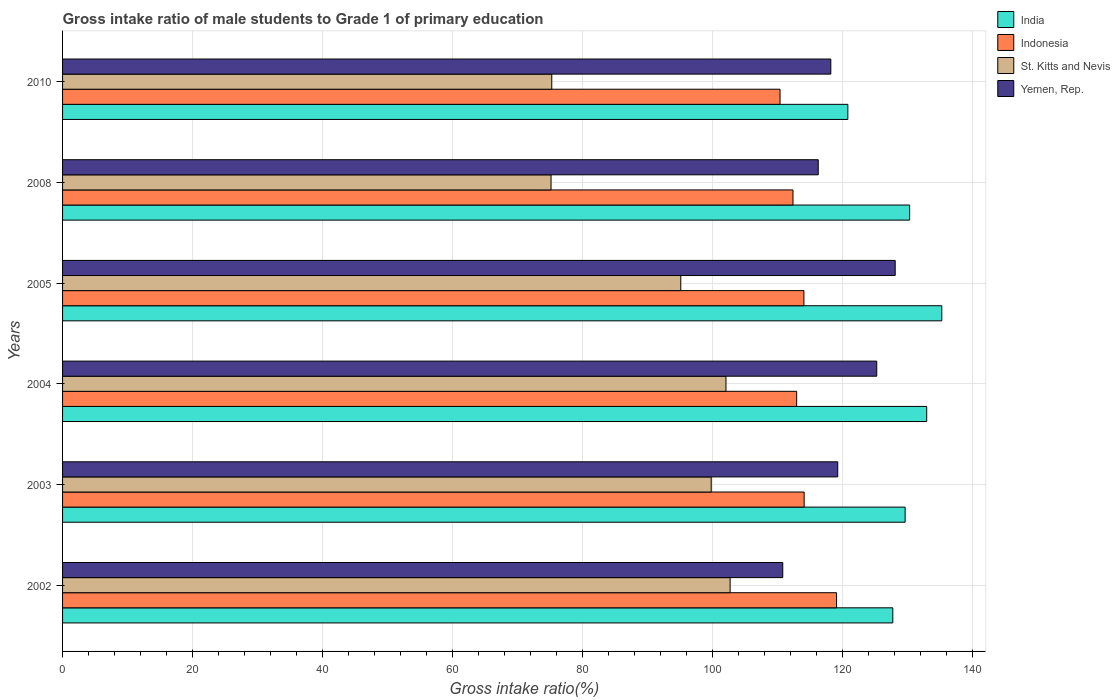How many different coloured bars are there?
Your response must be concise. 4. How many groups of bars are there?
Keep it short and to the point. 6. Are the number of bars per tick equal to the number of legend labels?
Keep it short and to the point. Yes. Are the number of bars on each tick of the Y-axis equal?
Offer a very short reply. Yes. What is the label of the 3rd group of bars from the top?
Offer a very short reply. 2005. In how many cases, is the number of bars for a given year not equal to the number of legend labels?
Provide a short and direct response. 0. What is the gross intake ratio in Yemen, Rep. in 2003?
Give a very brief answer. 119.26. Across all years, what is the maximum gross intake ratio in India?
Offer a very short reply. 135.27. Across all years, what is the minimum gross intake ratio in Yemen, Rep.?
Your answer should be very brief. 110.8. What is the total gross intake ratio in Indonesia in the graph?
Your answer should be compact. 682.92. What is the difference between the gross intake ratio in India in 2002 and that in 2004?
Keep it short and to the point. -5.22. What is the difference between the gross intake ratio in St. Kitts and Nevis in 2004 and the gross intake ratio in India in 2005?
Offer a terse response. -33.21. What is the average gross intake ratio in Yemen, Rep. per year?
Your answer should be compact. 119.65. In the year 2010, what is the difference between the gross intake ratio in St. Kitts and Nevis and gross intake ratio in Yemen, Rep.?
Your answer should be compact. -42.93. What is the ratio of the gross intake ratio in Indonesia in 2003 to that in 2005?
Your answer should be compact. 1. Is the difference between the gross intake ratio in St. Kitts and Nevis in 2004 and 2005 greater than the difference between the gross intake ratio in Yemen, Rep. in 2004 and 2005?
Your answer should be compact. Yes. What is the difference between the highest and the second highest gross intake ratio in Indonesia?
Provide a succinct answer. 4.98. What is the difference between the highest and the lowest gross intake ratio in Indonesia?
Your answer should be compact. 8.69. In how many years, is the gross intake ratio in Indonesia greater than the average gross intake ratio in Indonesia taken over all years?
Make the answer very short. 3. Is it the case that in every year, the sum of the gross intake ratio in St. Kitts and Nevis and gross intake ratio in Yemen, Rep. is greater than the sum of gross intake ratio in Indonesia and gross intake ratio in India?
Ensure brevity in your answer.  No. What does the 3rd bar from the bottom in 2002 represents?
Your answer should be compact. St. Kitts and Nevis. Is it the case that in every year, the sum of the gross intake ratio in Indonesia and gross intake ratio in India is greater than the gross intake ratio in Yemen, Rep.?
Offer a terse response. Yes. How many bars are there?
Your answer should be very brief. 24. Are all the bars in the graph horizontal?
Ensure brevity in your answer.  Yes. How many years are there in the graph?
Your response must be concise. 6. What is the difference between two consecutive major ticks on the X-axis?
Your answer should be compact. 20. Are the values on the major ticks of X-axis written in scientific E-notation?
Provide a short and direct response. No. Does the graph contain grids?
Your response must be concise. Yes. How many legend labels are there?
Offer a very short reply. 4. How are the legend labels stacked?
Provide a short and direct response. Vertical. What is the title of the graph?
Your response must be concise. Gross intake ratio of male students to Grade 1 of primary education. Does "Burkina Faso" appear as one of the legend labels in the graph?
Ensure brevity in your answer.  No. What is the label or title of the X-axis?
Your response must be concise. Gross intake ratio(%). What is the label or title of the Y-axis?
Provide a succinct answer. Years. What is the Gross intake ratio(%) of India in 2002?
Your answer should be compact. 127.73. What is the Gross intake ratio(%) of Indonesia in 2002?
Offer a terse response. 119.08. What is the Gross intake ratio(%) in St. Kitts and Nevis in 2002?
Provide a short and direct response. 102.7. What is the Gross intake ratio(%) of Yemen, Rep. in 2002?
Your response must be concise. 110.8. What is the Gross intake ratio(%) of India in 2003?
Ensure brevity in your answer.  129.63. What is the Gross intake ratio(%) in Indonesia in 2003?
Provide a succinct answer. 114.09. What is the Gross intake ratio(%) of St. Kitts and Nevis in 2003?
Provide a short and direct response. 99.79. What is the Gross intake ratio(%) of Yemen, Rep. in 2003?
Your response must be concise. 119.26. What is the Gross intake ratio(%) in India in 2004?
Give a very brief answer. 132.94. What is the Gross intake ratio(%) in Indonesia in 2004?
Offer a very short reply. 112.94. What is the Gross intake ratio(%) of St. Kitts and Nevis in 2004?
Give a very brief answer. 102.06. What is the Gross intake ratio(%) in Yemen, Rep. in 2004?
Give a very brief answer. 125.26. What is the Gross intake ratio(%) of India in 2005?
Give a very brief answer. 135.27. What is the Gross intake ratio(%) in Indonesia in 2005?
Your answer should be compact. 114.06. What is the Gross intake ratio(%) of St. Kitts and Nevis in 2005?
Your answer should be very brief. 95.11. What is the Gross intake ratio(%) in Yemen, Rep. in 2005?
Provide a succinct answer. 128.1. What is the Gross intake ratio(%) in India in 2008?
Your response must be concise. 130.32. What is the Gross intake ratio(%) in Indonesia in 2008?
Make the answer very short. 112.37. What is the Gross intake ratio(%) in St. Kitts and Nevis in 2008?
Offer a very short reply. 75.15. What is the Gross intake ratio(%) in Yemen, Rep. in 2008?
Give a very brief answer. 116.26. What is the Gross intake ratio(%) in India in 2010?
Offer a very short reply. 120.81. What is the Gross intake ratio(%) of Indonesia in 2010?
Provide a succinct answer. 110.38. What is the Gross intake ratio(%) of St. Kitts and Nevis in 2010?
Provide a short and direct response. 75.26. What is the Gross intake ratio(%) of Yemen, Rep. in 2010?
Your response must be concise. 118.19. Across all years, what is the maximum Gross intake ratio(%) in India?
Make the answer very short. 135.27. Across all years, what is the maximum Gross intake ratio(%) in Indonesia?
Ensure brevity in your answer.  119.08. Across all years, what is the maximum Gross intake ratio(%) of St. Kitts and Nevis?
Provide a short and direct response. 102.7. Across all years, what is the maximum Gross intake ratio(%) in Yemen, Rep.?
Provide a short and direct response. 128.1. Across all years, what is the minimum Gross intake ratio(%) in India?
Offer a terse response. 120.81. Across all years, what is the minimum Gross intake ratio(%) of Indonesia?
Your response must be concise. 110.38. Across all years, what is the minimum Gross intake ratio(%) of St. Kitts and Nevis?
Offer a very short reply. 75.15. Across all years, what is the minimum Gross intake ratio(%) of Yemen, Rep.?
Provide a succinct answer. 110.8. What is the total Gross intake ratio(%) in India in the graph?
Your answer should be very brief. 776.7. What is the total Gross intake ratio(%) of Indonesia in the graph?
Your answer should be compact. 682.92. What is the total Gross intake ratio(%) in St. Kitts and Nevis in the graph?
Ensure brevity in your answer.  550.08. What is the total Gross intake ratio(%) of Yemen, Rep. in the graph?
Offer a very short reply. 717.87. What is the difference between the Gross intake ratio(%) in India in 2002 and that in 2003?
Your answer should be compact. -1.9. What is the difference between the Gross intake ratio(%) in Indonesia in 2002 and that in 2003?
Keep it short and to the point. 4.98. What is the difference between the Gross intake ratio(%) of St. Kitts and Nevis in 2002 and that in 2003?
Your response must be concise. 2.91. What is the difference between the Gross intake ratio(%) in Yemen, Rep. in 2002 and that in 2003?
Make the answer very short. -8.46. What is the difference between the Gross intake ratio(%) of India in 2002 and that in 2004?
Offer a very short reply. -5.22. What is the difference between the Gross intake ratio(%) in Indonesia in 2002 and that in 2004?
Offer a very short reply. 6.14. What is the difference between the Gross intake ratio(%) in St. Kitts and Nevis in 2002 and that in 2004?
Ensure brevity in your answer.  0.64. What is the difference between the Gross intake ratio(%) in Yemen, Rep. in 2002 and that in 2004?
Your answer should be very brief. -14.46. What is the difference between the Gross intake ratio(%) in India in 2002 and that in 2005?
Make the answer very short. -7.54. What is the difference between the Gross intake ratio(%) in Indonesia in 2002 and that in 2005?
Offer a terse response. 5.02. What is the difference between the Gross intake ratio(%) in St. Kitts and Nevis in 2002 and that in 2005?
Your answer should be very brief. 7.59. What is the difference between the Gross intake ratio(%) of Yemen, Rep. in 2002 and that in 2005?
Your answer should be compact. -17.3. What is the difference between the Gross intake ratio(%) of India in 2002 and that in 2008?
Your answer should be very brief. -2.59. What is the difference between the Gross intake ratio(%) of Indonesia in 2002 and that in 2008?
Your response must be concise. 6.7. What is the difference between the Gross intake ratio(%) of St. Kitts and Nevis in 2002 and that in 2008?
Keep it short and to the point. 27.55. What is the difference between the Gross intake ratio(%) of Yemen, Rep. in 2002 and that in 2008?
Make the answer very short. -5.46. What is the difference between the Gross intake ratio(%) of India in 2002 and that in 2010?
Offer a very short reply. 6.92. What is the difference between the Gross intake ratio(%) in Indonesia in 2002 and that in 2010?
Your answer should be very brief. 8.69. What is the difference between the Gross intake ratio(%) in St. Kitts and Nevis in 2002 and that in 2010?
Keep it short and to the point. 27.44. What is the difference between the Gross intake ratio(%) in Yemen, Rep. in 2002 and that in 2010?
Your response must be concise. -7.39. What is the difference between the Gross intake ratio(%) of India in 2003 and that in 2004?
Your response must be concise. -3.32. What is the difference between the Gross intake ratio(%) of Indonesia in 2003 and that in 2004?
Your answer should be compact. 1.16. What is the difference between the Gross intake ratio(%) in St. Kitts and Nevis in 2003 and that in 2004?
Your answer should be compact. -2.27. What is the difference between the Gross intake ratio(%) of Yemen, Rep. in 2003 and that in 2004?
Your answer should be very brief. -6. What is the difference between the Gross intake ratio(%) in India in 2003 and that in 2005?
Make the answer very short. -5.64. What is the difference between the Gross intake ratio(%) in Indonesia in 2003 and that in 2005?
Keep it short and to the point. 0.04. What is the difference between the Gross intake ratio(%) of St. Kitts and Nevis in 2003 and that in 2005?
Your answer should be compact. 4.68. What is the difference between the Gross intake ratio(%) in Yemen, Rep. in 2003 and that in 2005?
Make the answer very short. -8.84. What is the difference between the Gross intake ratio(%) in India in 2003 and that in 2008?
Provide a succinct answer. -0.69. What is the difference between the Gross intake ratio(%) of Indonesia in 2003 and that in 2008?
Ensure brevity in your answer.  1.72. What is the difference between the Gross intake ratio(%) in St. Kitts and Nevis in 2003 and that in 2008?
Your response must be concise. 24.64. What is the difference between the Gross intake ratio(%) of Yemen, Rep. in 2003 and that in 2008?
Offer a terse response. 3. What is the difference between the Gross intake ratio(%) in India in 2003 and that in 2010?
Make the answer very short. 8.82. What is the difference between the Gross intake ratio(%) in Indonesia in 2003 and that in 2010?
Keep it short and to the point. 3.71. What is the difference between the Gross intake ratio(%) in St. Kitts and Nevis in 2003 and that in 2010?
Provide a succinct answer. 24.53. What is the difference between the Gross intake ratio(%) in Yemen, Rep. in 2003 and that in 2010?
Your answer should be compact. 1.06. What is the difference between the Gross intake ratio(%) in India in 2004 and that in 2005?
Offer a terse response. -2.32. What is the difference between the Gross intake ratio(%) of Indonesia in 2004 and that in 2005?
Give a very brief answer. -1.12. What is the difference between the Gross intake ratio(%) of St. Kitts and Nevis in 2004 and that in 2005?
Your answer should be very brief. 6.95. What is the difference between the Gross intake ratio(%) in Yemen, Rep. in 2004 and that in 2005?
Ensure brevity in your answer.  -2.84. What is the difference between the Gross intake ratio(%) in India in 2004 and that in 2008?
Provide a short and direct response. 2.62. What is the difference between the Gross intake ratio(%) of Indonesia in 2004 and that in 2008?
Offer a very short reply. 0.56. What is the difference between the Gross intake ratio(%) in St. Kitts and Nevis in 2004 and that in 2008?
Offer a very short reply. 26.91. What is the difference between the Gross intake ratio(%) in Yemen, Rep. in 2004 and that in 2008?
Your answer should be very brief. 9. What is the difference between the Gross intake ratio(%) of India in 2004 and that in 2010?
Your answer should be very brief. 12.13. What is the difference between the Gross intake ratio(%) of Indonesia in 2004 and that in 2010?
Ensure brevity in your answer.  2.56. What is the difference between the Gross intake ratio(%) in St. Kitts and Nevis in 2004 and that in 2010?
Provide a succinct answer. 26.8. What is the difference between the Gross intake ratio(%) in Yemen, Rep. in 2004 and that in 2010?
Offer a terse response. 7.07. What is the difference between the Gross intake ratio(%) of India in 2005 and that in 2008?
Give a very brief answer. 4.95. What is the difference between the Gross intake ratio(%) in Indonesia in 2005 and that in 2008?
Keep it short and to the point. 1.68. What is the difference between the Gross intake ratio(%) in St. Kitts and Nevis in 2005 and that in 2008?
Your response must be concise. 19.96. What is the difference between the Gross intake ratio(%) of Yemen, Rep. in 2005 and that in 2008?
Provide a succinct answer. 11.84. What is the difference between the Gross intake ratio(%) in India in 2005 and that in 2010?
Give a very brief answer. 14.46. What is the difference between the Gross intake ratio(%) in Indonesia in 2005 and that in 2010?
Ensure brevity in your answer.  3.67. What is the difference between the Gross intake ratio(%) in St. Kitts and Nevis in 2005 and that in 2010?
Offer a very short reply. 19.85. What is the difference between the Gross intake ratio(%) in Yemen, Rep. in 2005 and that in 2010?
Your response must be concise. 9.91. What is the difference between the Gross intake ratio(%) of India in 2008 and that in 2010?
Offer a very short reply. 9.51. What is the difference between the Gross intake ratio(%) in Indonesia in 2008 and that in 2010?
Your answer should be very brief. 1.99. What is the difference between the Gross intake ratio(%) in St. Kitts and Nevis in 2008 and that in 2010?
Offer a terse response. -0.11. What is the difference between the Gross intake ratio(%) of Yemen, Rep. in 2008 and that in 2010?
Make the answer very short. -1.93. What is the difference between the Gross intake ratio(%) of India in 2002 and the Gross intake ratio(%) of Indonesia in 2003?
Provide a succinct answer. 13.64. What is the difference between the Gross intake ratio(%) in India in 2002 and the Gross intake ratio(%) in St. Kitts and Nevis in 2003?
Your answer should be very brief. 27.94. What is the difference between the Gross intake ratio(%) in India in 2002 and the Gross intake ratio(%) in Yemen, Rep. in 2003?
Provide a short and direct response. 8.47. What is the difference between the Gross intake ratio(%) of Indonesia in 2002 and the Gross intake ratio(%) of St. Kitts and Nevis in 2003?
Provide a short and direct response. 19.28. What is the difference between the Gross intake ratio(%) of Indonesia in 2002 and the Gross intake ratio(%) of Yemen, Rep. in 2003?
Ensure brevity in your answer.  -0.18. What is the difference between the Gross intake ratio(%) of St. Kitts and Nevis in 2002 and the Gross intake ratio(%) of Yemen, Rep. in 2003?
Keep it short and to the point. -16.55. What is the difference between the Gross intake ratio(%) of India in 2002 and the Gross intake ratio(%) of Indonesia in 2004?
Provide a short and direct response. 14.79. What is the difference between the Gross intake ratio(%) in India in 2002 and the Gross intake ratio(%) in St. Kitts and Nevis in 2004?
Ensure brevity in your answer.  25.67. What is the difference between the Gross intake ratio(%) in India in 2002 and the Gross intake ratio(%) in Yemen, Rep. in 2004?
Your answer should be very brief. 2.47. What is the difference between the Gross intake ratio(%) of Indonesia in 2002 and the Gross intake ratio(%) of St. Kitts and Nevis in 2004?
Your response must be concise. 17.01. What is the difference between the Gross intake ratio(%) of Indonesia in 2002 and the Gross intake ratio(%) of Yemen, Rep. in 2004?
Give a very brief answer. -6.19. What is the difference between the Gross intake ratio(%) of St. Kitts and Nevis in 2002 and the Gross intake ratio(%) of Yemen, Rep. in 2004?
Your answer should be compact. -22.56. What is the difference between the Gross intake ratio(%) of India in 2002 and the Gross intake ratio(%) of Indonesia in 2005?
Provide a short and direct response. 13.67. What is the difference between the Gross intake ratio(%) in India in 2002 and the Gross intake ratio(%) in St. Kitts and Nevis in 2005?
Offer a very short reply. 32.62. What is the difference between the Gross intake ratio(%) in India in 2002 and the Gross intake ratio(%) in Yemen, Rep. in 2005?
Your answer should be very brief. -0.37. What is the difference between the Gross intake ratio(%) of Indonesia in 2002 and the Gross intake ratio(%) of St. Kitts and Nevis in 2005?
Provide a succinct answer. 23.96. What is the difference between the Gross intake ratio(%) of Indonesia in 2002 and the Gross intake ratio(%) of Yemen, Rep. in 2005?
Offer a terse response. -9.02. What is the difference between the Gross intake ratio(%) in St. Kitts and Nevis in 2002 and the Gross intake ratio(%) in Yemen, Rep. in 2005?
Provide a short and direct response. -25.4. What is the difference between the Gross intake ratio(%) in India in 2002 and the Gross intake ratio(%) in Indonesia in 2008?
Provide a short and direct response. 15.36. What is the difference between the Gross intake ratio(%) in India in 2002 and the Gross intake ratio(%) in St. Kitts and Nevis in 2008?
Your answer should be compact. 52.58. What is the difference between the Gross intake ratio(%) in India in 2002 and the Gross intake ratio(%) in Yemen, Rep. in 2008?
Ensure brevity in your answer.  11.47. What is the difference between the Gross intake ratio(%) of Indonesia in 2002 and the Gross intake ratio(%) of St. Kitts and Nevis in 2008?
Give a very brief answer. 43.92. What is the difference between the Gross intake ratio(%) in Indonesia in 2002 and the Gross intake ratio(%) in Yemen, Rep. in 2008?
Make the answer very short. 2.81. What is the difference between the Gross intake ratio(%) in St. Kitts and Nevis in 2002 and the Gross intake ratio(%) in Yemen, Rep. in 2008?
Provide a succinct answer. -13.56. What is the difference between the Gross intake ratio(%) of India in 2002 and the Gross intake ratio(%) of Indonesia in 2010?
Provide a succinct answer. 17.35. What is the difference between the Gross intake ratio(%) in India in 2002 and the Gross intake ratio(%) in St. Kitts and Nevis in 2010?
Offer a very short reply. 52.47. What is the difference between the Gross intake ratio(%) of India in 2002 and the Gross intake ratio(%) of Yemen, Rep. in 2010?
Your answer should be very brief. 9.54. What is the difference between the Gross intake ratio(%) in Indonesia in 2002 and the Gross intake ratio(%) in St. Kitts and Nevis in 2010?
Offer a terse response. 43.81. What is the difference between the Gross intake ratio(%) of Indonesia in 2002 and the Gross intake ratio(%) of Yemen, Rep. in 2010?
Provide a short and direct response. 0.88. What is the difference between the Gross intake ratio(%) of St. Kitts and Nevis in 2002 and the Gross intake ratio(%) of Yemen, Rep. in 2010?
Your answer should be very brief. -15.49. What is the difference between the Gross intake ratio(%) of India in 2003 and the Gross intake ratio(%) of Indonesia in 2004?
Keep it short and to the point. 16.69. What is the difference between the Gross intake ratio(%) in India in 2003 and the Gross intake ratio(%) in St. Kitts and Nevis in 2004?
Keep it short and to the point. 27.57. What is the difference between the Gross intake ratio(%) of India in 2003 and the Gross intake ratio(%) of Yemen, Rep. in 2004?
Provide a short and direct response. 4.37. What is the difference between the Gross intake ratio(%) in Indonesia in 2003 and the Gross intake ratio(%) in St. Kitts and Nevis in 2004?
Offer a terse response. 12.03. What is the difference between the Gross intake ratio(%) in Indonesia in 2003 and the Gross intake ratio(%) in Yemen, Rep. in 2004?
Provide a short and direct response. -11.17. What is the difference between the Gross intake ratio(%) in St. Kitts and Nevis in 2003 and the Gross intake ratio(%) in Yemen, Rep. in 2004?
Your answer should be very brief. -25.47. What is the difference between the Gross intake ratio(%) of India in 2003 and the Gross intake ratio(%) of Indonesia in 2005?
Your response must be concise. 15.57. What is the difference between the Gross intake ratio(%) in India in 2003 and the Gross intake ratio(%) in St. Kitts and Nevis in 2005?
Ensure brevity in your answer.  34.52. What is the difference between the Gross intake ratio(%) in India in 2003 and the Gross intake ratio(%) in Yemen, Rep. in 2005?
Ensure brevity in your answer.  1.53. What is the difference between the Gross intake ratio(%) of Indonesia in 2003 and the Gross intake ratio(%) of St. Kitts and Nevis in 2005?
Give a very brief answer. 18.98. What is the difference between the Gross intake ratio(%) of Indonesia in 2003 and the Gross intake ratio(%) of Yemen, Rep. in 2005?
Ensure brevity in your answer.  -14.01. What is the difference between the Gross intake ratio(%) of St. Kitts and Nevis in 2003 and the Gross intake ratio(%) of Yemen, Rep. in 2005?
Keep it short and to the point. -28.31. What is the difference between the Gross intake ratio(%) in India in 2003 and the Gross intake ratio(%) in Indonesia in 2008?
Provide a short and direct response. 17.25. What is the difference between the Gross intake ratio(%) in India in 2003 and the Gross intake ratio(%) in St. Kitts and Nevis in 2008?
Provide a short and direct response. 54.48. What is the difference between the Gross intake ratio(%) in India in 2003 and the Gross intake ratio(%) in Yemen, Rep. in 2008?
Make the answer very short. 13.37. What is the difference between the Gross intake ratio(%) of Indonesia in 2003 and the Gross intake ratio(%) of St. Kitts and Nevis in 2008?
Give a very brief answer. 38.94. What is the difference between the Gross intake ratio(%) of Indonesia in 2003 and the Gross intake ratio(%) of Yemen, Rep. in 2008?
Provide a short and direct response. -2.17. What is the difference between the Gross intake ratio(%) of St. Kitts and Nevis in 2003 and the Gross intake ratio(%) of Yemen, Rep. in 2008?
Keep it short and to the point. -16.47. What is the difference between the Gross intake ratio(%) in India in 2003 and the Gross intake ratio(%) in Indonesia in 2010?
Ensure brevity in your answer.  19.25. What is the difference between the Gross intake ratio(%) of India in 2003 and the Gross intake ratio(%) of St. Kitts and Nevis in 2010?
Offer a very short reply. 54.37. What is the difference between the Gross intake ratio(%) of India in 2003 and the Gross intake ratio(%) of Yemen, Rep. in 2010?
Your answer should be compact. 11.43. What is the difference between the Gross intake ratio(%) of Indonesia in 2003 and the Gross intake ratio(%) of St. Kitts and Nevis in 2010?
Provide a succinct answer. 38.83. What is the difference between the Gross intake ratio(%) of Indonesia in 2003 and the Gross intake ratio(%) of Yemen, Rep. in 2010?
Your response must be concise. -4.1. What is the difference between the Gross intake ratio(%) of St. Kitts and Nevis in 2003 and the Gross intake ratio(%) of Yemen, Rep. in 2010?
Provide a succinct answer. -18.4. What is the difference between the Gross intake ratio(%) in India in 2004 and the Gross intake ratio(%) in Indonesia in 2005?
Ensure brevity in your answer.  18.89. What is the difference between the Gross intake ratio(%) in India in 2004 and the Gross intake ratio(%) in St. Kitts and Nevis in 2005?
Your response must be concise. 37.83. What is the difference between the Gross intake ratio(%) in India in 2004 and the Gross intake ratio(%) in Yemen, Rep. in 2005?
Your answer should be compact. 4.85. What is the difference between the Gross intake ratio(%) in Indonesia in 2004 and the Gross intake ratio(%) in St. Kitts and Nevis in 2005?
Offer a very short reply. 17.83. What is the difference between the Gross intake ratio(%) in Indonesia in 2004 and the Gross intake ratio(%) in Yemen, Rep. in 2005?
Make the answer very short. -15.16. What is the difference between the Gross intake ratio(%) in St. Kitts and Nevis in 2004 and the Gross intake ratio(%) in Yemen, Rep. in 2005?
Provide a succinct answer. -26.04. What is the difference between the Gross intake ratio(%) in India in 2004 and the Gross intake ratio(%) in Indonesia in 2008?
Ensure brevity in your answer.  20.57. What is the difference between the Gross intake ratio(%) in India in 2004 and the Gross intake ratio(%) in St. Kitts and Nevis in 2008?
Give a very brief answer. 57.79. What is the difference between the Gross intake ratio(%) in India in 2004 and the Gross intake ratio(%) in Yemen, Rep. in 2008?
Give a very brief answer. 16.68. What is the difference between the Gross intake ratio(%) in Indonesia in 2004 and the Gross intake ratio(%) in St. Kitts and Nevis in 2008?
Your response must be concise. 37.78. What is the difference between the Gross intake ratio(%) of Indonesia in 2004 and the Gross intake ratio(%) of Yemen, Rep. in 2008?
Ensure brevity in your answer.  -3.32. What is the difference between the Gross intake ratio(%) in St. Kitts and Nevis in 2004 and the Gross intake ratio(%) in Yemen, Rep. in 2008?
Your response must be concise. -14.2. What is the difference between the Gross intake ratio(%) in India in 2004 and the Gross intake ratio(%) in Indonesia in 2010?
Ensure brevity in your answer.  22.56. What is the difference between the Gross intake ratio(%) of India in 2004 and the Gross intake ratio(%) of St. Kitts and Nevis in 2010?
Your response must be concise. 57.68. What is the difference between the Gross intake ratio(%) in India in 2004 and the Gross intake ratio(%) in Yemen, Rep. in 2010?
Provide a succinct answer. 14.75. What is the difference between the Gross intake ratio(%) of Indonesia in 2004 and the Gross intake ratio(%) of St. Kitts and Nevis in 2010?
Give a very brief answer. 37.68. What is the difference between the Gross intake ratio(%) in Indonesia in 2004 and the Gross intake ratio(%) in Yemen, Rep. in 2010?
Offer a terse response. -5.26. What is the difference between the Gross intake ratio(%) in St. Kitts and Nevis in 2004 and the Gross intake ratio(%) in Yemen, Rep. in 2010?
Your response must be concise. -16.13. What is the difference between the Gross intake ratio(%) in India in 2005 and the Gross intake ratio(%) in Indonesia in 2008?
Your answer should be very brief. 22.89. What is the difference between the Gross intake ratio(%) of India in 2005 and the Gross intake ratio(%) of St. Kitts and Nevis in 2008?
Make the answer very short. 60.11. What is the difference between the Gross intake ratio(%) in India in 2005 and the Gross intake ratio(%) in Yemen, Rep. in 2008?
Provide a succinct answer. 19.01. What is the difference between the Gross intake ratio(%) of Indonesia in 2005 and the Gross intake ratio(%) of St. Kitts and Nevis in 2008?
Provide a short and direct response. 38.9. What is the difference between the Gross intake ratio(%) of Indonesia in 2005 and the Gross intake ratio(%) of Yemen, Rep. in 2008?
Give a very brief answer. -2.21. What is the difference between the Gross intake ratio(%) in St. Kitts and Nevis in 2005 and the Gross intake ratio(%) in Yemen, Rep. in 2008?
Your answer should be compact. -21.15. What is the difference between the Gross intake ratio(%) of India in 2005 and the Gross intake ratio(%) of Indonesia in 2010?
Keep it short and to the point. 24.89. What is the difference between the Gross intake ratio(%) of India in 2005 and the Gross intake ratio(%) of St. Kitts and Nevis in 2010?
Your response must be concise. 60.01. What is the difference between the Gross intake ratio(%) in India in 2005 and the Gross intake ratio(%) in Yemen, Rep. in 2010?
Keep it short and to the point. 17.07. What is the difference between the Gross intake ratio(%) in Indonesia in 2005 and the Gross intake ratio(%) in St. Kitts and Nevis in 2010?
Offer a terse response. 38.79. What is the difference between the Gross intake ratio(%) of Indonesia in 2005 and the Gross intake ratio(%) of Yemen, Rep. in 2010?
Your answer should be very brief. -4.14. What is the difference between the Gross intake ratio(%) of St. Kitts and Nevis in 2005 and the Gross intake ratio(%) of Yemen, Rep. in 2010?
Provide a short and direct response. -23.08. What is the difference between the Gross intake ratio(%) in India in 2008 and the Gross intake ratio(%) in Indonesia in 2010?
Ensure brevity in your answer.  19.94. What is the difference between the Gross intake ratio(%) of India in 2008 and the Gross intake ratio(%) of St. Kitts and Nevis in 2010?
Offer a terse response. 55.06. What is the difference between the Gross intake ratio(%) of India in 2008 and the Gross intake ratio(%) of Yemen, Rep. in 2010?
Make the answer very short. 12.13. What is the difference between the Gross intake ratio(%) of Indonesia in 2008 and the Gross intake ratio(%) of St. Kitts and Nevis in 2010?
Your answer should be compact. 37.11. What is the difference between the Gross intake ratio(%) in Indonesia in 2008 and the Gross intake ratio(%) in Yemen, Rep. in 2010?
Provide a succinct answer. -5.82. What is the difference between the Gross intake ratio(%) in St. Kitts and Nevis in 2008 and the Gross intake ratio(%) in Yemen, Rep. in 2010?
Offer a very short reply. -43.04. What is the average Gross intake ratio(%) of India per year?
Offer a very short reply. 129.45. What is the average Gross intake ratio(%) of Indonesia per year?
Your answer should be compact. 113.82. What is the average Gross intake ratio(%) in St. Kitts and Nevis per year?
Provide a short and direct response. 91.68. What is the average Gross intake ratio(%) in Yemen, Rep. per year?
Your answer should be very brief. 119.65. In the year 2002, what is the difference between the Gross intake ratio(%) of India and Gross intake ratio(%) of Indonesia?
Your response must be concise. 8.65. In the year 2002, what is the difference between the Gross intake ratio(%) in India and Gross intake ratio(%) in St. Kitts and Nevis?
Provide a succinct answer. 25.03. In the year 2002, what is the difference between the Gross intake ratio(%) of India and Gross intake ratio(%) of Yemen, Rep.?
Provide a succinct answer. 16.93. In the year 2002, what is the difference between the Gross intake ratio(%) in Indonesia and Gross intake ratio(%) in St. Kitts and Nevis?
Make the answer very short. 16.37. In the year 2002, what is the difference between the Gross intake ratio(%) of Indonesia and Gross intake ratio(%) of Yemen, Rep.?
Provide a short and direct response. 8.27. In the year 2002, what is the difference between the Gross intake ratio(%) of St. Kitts and Nevis and Gross intake ratio(%) of Yemen, Rep.?
Offer a very short reply. -8.1. In the year 2003, what is the difference between the Gross intake ratio(%) in India and Gross intake ratio(%) in Indonesia?
Provide a succinct answer. 15.54. In the year 2003, what is the difference between the Gross intake ratio(%) in India and Gross intake ratio(%) in St. Kitts and Nevis?
Your answer should be very brief. 29.84. In the year 2003, what is the difference between the Gross intake ratio(%) in India and Gross intake ratio(%) in Yemen, Rep.?
Ensure brevity in your answer.  10.37. In the year 2003, what is the difference between the Gross intake ratio(%) in Indonesia and Gross intake ratio(%) in St. Kitts and Nevis?
Your answer should be very brief. 14.3. In the year 2003, what is the difference between the Gross intake ratio(%) of Indonesia and Gross intake ratio(%) of Yemen, Rep.?
Your response must be concise. -5.17. In the year 2003, what is the difference between the Gross intake ratio(%) in St. Kitts and Nevis and Gross intake ratio(%) in Yemen, Rep.?
Ensure brevity in your answer.  -19.47. In the year 2004, what is the difference between the Gross intake ratio(%) of India and Gross intake ratio(%) of Indonesia?
Keep it short and to the point. 20.01. In the year 2004, what is the difference between the Gross intake ratio(%) in India and Gross intake ratio(%) in St. Kitts and Nevis?
Provide a succinct answer. 30.88. In the year 2004, what is the difference between the Gross intake ratio(%) of India and Gross intake ratio(%) of Yemen, Rep.?
Offer a terse response. 7.68. In the year 2004, what is the difference between the Gross intake ratio(%) in Indonesia and Gross intake ratio(%) in St. Kitts and Nevis?
Provide a short and direct response. 10.88. In the year 2004, what is the difference between the Gross intake ratio(%) in Indonesia and Gross intake ratio(%) in Yemen, Rep.?
Offer a very short reply. -12.32. In the year 2004, what is the difference between the Gross intake ratio(%) in St. Kitts and Nevis and Gross intake ratio(%) in Yemen, Rep.?
Provide a succinct answer. -23.2. In the year 2005, what is the difference between the Gross intake ratio(%) in India and Gross intake ratio(%) in Indonesia?
Provide a succinct answer. 21.21. In the year 2005, what is the difference between the Gross intake ratio(%) of India and Gross intake ratio(%) of St. Kitts and Nevis?
Offer a terse response. 40.16. In the year 2005, what is the difference between the Gross intake ratio(%) in India and Gross intake ratio(%) in Yemen, Rep.?
Ensure brevity in your answer.  7.17. In the year 2005, what is the difference between the Gross intake ratio(%) of Indonesia and Gross intake ratio(%) of St. Kitts and Nevis?
Offer a terse response. 18.94. In the year 2005, what is the difference between the Gross intake ratio(%) in Indonesia and Gross intake ratio(%) in Yemen, Rep.?
Offer a terse response. -14.04. In the year 2005, what is the difference between the Gross intake ratio(%) of St. Kitts and Nevis and Gross intake ratio(%) of Yemen, Rep.?
Give a very brief answer. -32.99. In the year 2008, what is the difference between the Gross intake ratio(%) of India and Gross intake ratio(%) of Indonesia?
Your response must be concise. 17.95. In the year 2008, what is the difference between the Gross intake ratio(%) of India and Gross intake ratio(%) of St. Kitts and Nevis?
Your answer should be compact. 55.17. In the year 2008, what is the difference between the Gross intake ratio(%) of India and Gross intake ratio(%) of Yemen, Rep.?
Keep it short and to the point. 14.06. In the year 2008, what is the difference between the Gross intake ratio(%) of Indonesia and Gross intake ratio(%) of St. Kitts and Nevis?
Your answer should be very brief. 37.22. In the year 2008, what is the difference between the Gross intake ratio(%) of Indonesia and Gross intake ratio(%) of Yemen, Rep.?
Your answer should be compact. -3.89. In the year 2008, what is the difference between the Gross intake ratio(%) of St. Kitts and Nevis and Gross intake ratio(%) of Yemen, Rep.?
Offer a very short reply. -41.11. In the year 2010, what is the difference between the Gross intake ratio(%) of India and Gross intake ratio(%) of Indonesia?
Ensure brevity in your answer.  10.43. In the year 2010, what is the difference between the Gross intake ratio(%) in India and Gross intake ratio(%) in St. Kitts and Nevis?
Keep it short and to the point. 45.55. In the year 2010, what is the difference between the Gross intake ratio(%) of India and Gross intake ratio(%) of Yemen, Rep.?
Your answer should be very brief. 2.62. In the year 2010, what is the difference between the Gross intake ratio(%) in Indonesia and Gross intake ratio(%) in St. Kitts and Nevis?
Offer a very short reply. 35.12. In the year 2010, what is the difference between the Gross intake ratio(%) of Indonesia and Gross intake ratio(%) of Yemen, Rep.?
Provide a succinct answer. -7.81. In the year 2010, what is the difference between the Gross intake ratio(%) of St. Kitts and Nevis and Gross intake ratio(%) of Yemen, Rep.?
Provide a succinct answer. -42.93. What is the ratio of the Gross intake ratio(%) of India in 2002 to that in 2003?
Give a very brief answer. 0.99. What is the ratio of the Gross intake ratio(%) in Indonesia in 2002 to that in 2003?
Give a very brief answer. 1.04. What is the ratio of the Gross intake ratio(%) in St. Kitts and Nevis in 2002 to that in 2003?
Give a very brief answer. 1.03. What is the ratio of the Gross intake ratio(%) of Yemen, Rep. in 2002 to that in 2003?
Give a very brief answer. 0.93. What is the ratio of the Gross intake ratio(%) in India in 2002 to that in 2004?
Give a very brief answer. 0.96. What is the ratio of the Gross intake ratio(%) in Indonesia in 2002 to that in 2004?
Give a very brief answer. 1.05. What is the ratio of the Gross intake ratio(%) of St. Kitts and Nevis in 2002 to that in 2004?
Offer a terse response. 1.01. What is the ratio of the Gross intake ratio(%) in Yemen, Rep. in 2002 to that in 2004?
Offer a terse response. 0.88. What is the ratio of the Gross intake ratio(%) of India in 2002 to that in 2005?
Provide a short and direct response. 0.94. What is the ratio of the Gross intake ratio(%) in Indonesia in 2002 to that in 2005?
Provide a succinct answer. 1.04. What is the ratio of the Gross intake ratio(%) of St. Kitts and Nevis in 2002 to that in 2005?
Your answer should be very brief. 1.08. What is the ratio of the Gross intake ratio(%) in Yemen, Rep. in 2002 to that in 2005?
Your answer should be compact. 0.86. What is the ratio of the Gross intake ratio(%) of India in 2002 to that in 2008?
Ensure brevity in your answer.  0.98. What is the ratio of the Gross intake ratio(%) of Indonesia in 2002 to that in 2008?
Offer a terse response. 1.06. What is the ratio of the Gross intake ratio(%) of St. Kitts and Nevis in 2002 to that in 2008?
Make the answer very short. 1.37. What is the ratio of the Gross intake ratio(%) of Yemen, Rep. in 2002 to that in 2008?
Give a very brief answer. 0.95. What is the ratio of the Gross intake ratio(%) of India in 2002 to that in 2010?
Provide a succinct answer. 1.06. What is the ratio of the Gross intake ratio(%) in Indonesia in 2002 to that in 2010?
Provide a short and direct response. 1.08. What is the ratio of the Gross intake ratio(%) of St. Kitts and Nevis in 2002 to that in 2010?
Give a very brief answer. 1.36. What is the ratio of the Gross intake ratio(%) in India in 2003 to that in 2004?
Your answer should be very brief. 0.97. What is the ratio of the Gross intake ratio(%) in Indonesia in 2003 to that in 2004?
Ensure brevity in your answer.  1.01. What is the ratio of the Gross intake ratio(%) of St. Kitts and Nevis in 2003 to that in 2004?
Make the answer very short. 0.98. What is the ratio of the Gross intake ratio(%) in Yemen, Rep. in 2003 to that in 2004?
Your answer should be compact. 0.95. What is the ratio of the Gross intake ratio(%) of Indonesia in 2003 to that in 2005?
Keep it short and to the point. 1. What is the ratio of the Gross intake ratio(%) of St. Kitts and Nevis in 2003 to that in 2005?
Give a very brief answer. 1.05. What is the ratio of the Gross intake ratio(%) in India in 2003 to that in 2008?
Your response must be concise. 0.99. What is the ratio of the Gross intake ratio(%) in Indonesia in 2003 to that in 2008?
Provide a short and direct response. 1.02. What is the ratio of the Gross intake ratio(%) in St. Kitts and Nevis in 2003 to that in 2008?
Your answer should be very brief. 1.33. What is the ratio of the Gross intake ratio(%) of Yemen, Rep. in 2003 to that in 2008?
Give a very brief answer. 1.03. What is the ratio of the Gross intake ratio(%) in India in 2003 to that in 2010?
Provide a succinct answer. 1.07. What is the ratio of the Gross intake ratio(%) of Indonesia in 2003 to that in 2010?
Offer a terse response. 1.03. What is the ratio of the Gross intake ratio(%) of St. Kitts and Nevis in 2003 to that in 2010?
Keep it short and to the point. 1.33. What is the ratio of the Gross intake ratio(%) in India in 2004 to that in 2005?
Offer a terse response. 0.98. What is the ratio of the Gross intake ratio(%) in Indonesia in 2004 to that in 2005?
Your answer should be compact. 0.99. What is the ratio of the Gross intake ratio(%) of St. Kitts and Nevis in 2004 to that in 2005?
Provide a short and direct response. 1.07. What is the ratio of the Gross intake ratio(%) in Yemen, Rep. in 2004 to that in 2005?
Keep it short and to the point. 0.98. What is the ratio of the Gross intake ratio(%) in India in 2004 to that in 2008?
Keep it short and to the point. 1.02. What is the ratio of the Gross intake ratio(%) in St. Kitts and Nevis in 2004 to that in 2008?
Give a very brief answer. 1.36. What is the ratio of the Gross intake ratio(%) of Yemen, Rep. in 2004 to that in 2008?
Provide a short and direct response. 1.08. What is the ratio of the Gross intake ratio(%) of India in 2004 to that in 2010?
Provide a short and direct response. 1.1. What is the ratio of the Gross intake ratio(%) of Indonesia in 2004 to that in 2010?
Your answer should be very brief. 1.02. What is the ratio of the Gross intake ratio(%) of St. Kitts and Nevis in 2004 to that in 2010?
Provide a succinct answer. 1.36. What is the ratio of the Gross intake ratio(%) in Yemen, Rep. in 2004 to that in 2010?
Your response must be concise. 1.06. What is the ratio of the Gross intake ratio(%) of India in 2005 to that in 2008?
Offer a terse response. 1.04. What is the ratio of the Gross intake ratio(%) of Indonesia in 2005 to that in 2008?
Offer a very short reply. 1.01. What is the ratio of the Gross intake ratio(%) in St. Kitts and Nevis in 2005 to that in 2008?
Make the answer very short. 1.27. What is the ratio of the Gross intake ratio(%) of Yemen, Rep. in 2005 to that in 2008?
Ensure brevity in your answer.  1.1. What is the ratio of the Gross intake ratio(%) of India in 2005 to that in 2010?
Your answer should be very brief. 1.12. What is the ratio of the Gross intake ratio(%) of St. Kitts and Nevis in 2005 to that in 2010?
Ensure brevity in your answer.  1.26. What is the ratio of the Gross intake ratio(%) of Yemen, Rep. in 2005 to that in 2010?
Make the answer very short. 1.08. What is the ratio of the Gross intake ratio(%) of India in 2008 to that in 2010?
Give a very brief answer. 1.08. What is the ratio of the Gross intake ratio(%) of St. Kitts and Nevis in 2008 to that in 2010?
Give a very brief answer. 1. What is the ratio of the Gross intake ratio(%) of Yemen, Rep. in 2008 to that in 2010?
Provide a succinct answer. 0.98. What is the difference between the highest and the second highest Gross intake ratio(%) in India?
Offer a very short reply. 2.32. What is the difference between the highest and the second highest Gross intake ratio(%) of Indonesia?
Give a very brief answer. 4.98. What is the difference between the highest and the second highest Gross intake ratio(%) in St. Kitts and Nevis?
Provide a short and direct response. 0.64. What is the difference between the highest and the second highest Gross intake ratio(%) of Yemen, Rep.?
Ensure brevity in your answer.  2.84. What is the difference between the highest and the lowest Gross intake ratio(%) of India?
Your answer should be compact. 14.46. What is the difference between the highest and the lowest Gross intake ratio(%) of Indonesia?
Your answer should be compact. 8.69. What is the difference between the highest and the lowest Gross intake ratio(%) in St. Kitts and Nevis?
Your answer should be compact. 27.55. What is the difference between the highest and the lowest Gross intake ratio(%) of Yemen, Rep.?
Keep it short and to the point. 17.3. 